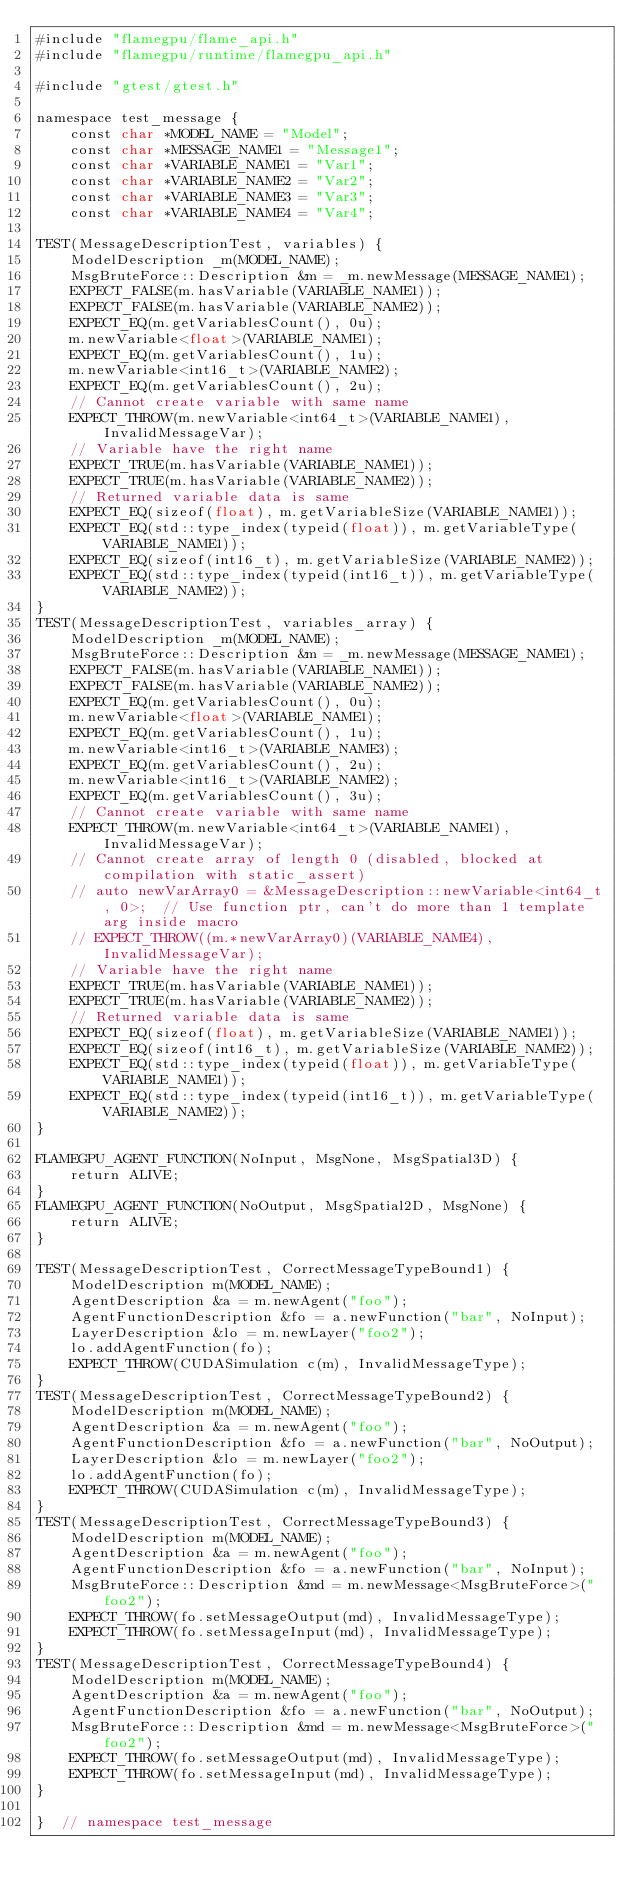<code> <loc_0><loc_0><loc_500><loc_500><_Cuda_>#include "flamegpu/flame_api.h"
#include "flamegpu/runtime/flamegpu_api.h"

#include "gtest/gtest.h"

namespace test_message {
    const char *MODEL_NAME = "Model";
    const char *MESSAGE_NAME1 = "Message1";
    const char *VARIABLE_NAME1 = "Var1";
    const char *VARIABLE_NAME2 = "Var2";
    const char *VARIABLE_NAME3 = "Var3";
    const char *VARIABLE_NAME4 = "Var4";

TEST(MessageDescriptionTest, variables) {
    ModelDescription _m(MODEL_NAME);
    MsgBruteForce::Description &m = _m.newMessage(MESSAGE_NAME1);
    EXPECT_FALSE(m.hasVariable(VARIABLE_NAME1));
    EXPECT_FALSE(m.hasVariable(VARIABLE_NAME2));
    EXPECT_EQ(m.getVariablesCount(), 0u);
    m.newVariable<float>(VARIABLE_NAME1);
    EXPECT_EQ(m.getVariablesCount(), 1u);
    m.newVariable<int16_t>(VARIABLE_NAME2);
    EXPECT_EQ(m.getVariablesCount(), 2u);
    // Cannot create variable with same name
    EXPECT_THROW(m.newVariable<int64_t>(VARIABLE_NAME1), InvalidMessageVar);
    // Variable have the right name
    EXPECT_TRUE(m.hasVariable(VARIABLE_NAME1));
    EXPECT_TRUE(m.hasVariable(VARIABLE_NAME2));
    // Returned variable data is same
    EXPECT_EQ(sizeof(float), m.getVariableSize(VARIABLE_NAME1));
    EXPECT_EQ(std::type_index(typeid(float)), m.getVariableType(VARIABLE_NAME1));
    EXPECT_EQ(sizeof(int16_t), m.getVariableSize(VARIABLE_NAME2));
    EXPECT_EQ(std::type_index(typeid(int16_t)), m.getVariableType(VARIABLE_NAME2));
}
TEST(MessageDescriptionTest, variables_array) {
    ModelDescription _m(MODEL_NAME);
    MsgBruteForce::Description &m = _m.newMessage(MESSAGE_NAME1);
    EXPECT_FALSE(m.hasVariable(VARIABLE_NAME1));
    EXPECT_FALSE(m.hasVariable(VARIABLE_NAME2));
    EXPECT_EQ(m.getVariablesCount(), 0u);
    m.newVariable<float>(VARIABLE_NAME1);
    EXPECT_EQ(m.getVariablesCount(), 1u);
    m.newVariable<int16_t>(VARIABLE_NAME3);
    EXPECT_EQ(m.getVariablesCount(), 2u);
    m.newVariable<int16_t>(VARIABLE_NAME2);
    EXPECT_EQ(m.getVariablesCount(), 3u);
    // Cannot create variable with same name
    EXPECT_THROW(m.newVariable<int64_t>(VARIABLE_NAME1), InvalidMessageVar);
    // Cannot create array of length 0 (disabled, blocked at compilation with static_assert)
    // auto newVarArray0 = &MessageDescription::newVariable<int64_t, 0>;  // Use function ptr, can't do more than 1 template arg inside macro
    // EXPECT_THROW((m.*newVarArray0)(VARIABLE_NAME4), InvalidMessageVar);
    // Variable have the right name
    EXPECT_TRUE(m.hasVariable(VARIABLE_NAME1));
    EXPECT_TRUE(m.hasVariable(VARIABLE_NAME2));
    // Returned variable data is same
    EXPECT_EQ(sizeof(float), m.getVariableSize(VARIABLE_NAME1));
    EXPECT_EQ(sizeof(int16_t), m.getVariableSize(VARIABLE_NAME2));
    EXPECT_EQ(std::type_index(typeid(float)), m.getVariableType(VARIABLE_NAME1));
    EXPECT_EQ(std::type_index(typeid(int16_t)), m.getVariableType(VARIABLE_NAME2));
}

FLAMEGPU_AGENT_FUNCTION(NoInput, MsgNone, MsgSpatial3D) {
    return ALIVE;
}
FLAMEGPU_AGENT_FUNCTION(NoOutput, MsgSpatial2D, MsgNone) {
    return ALIVE;
}

TEST(MessageDescriptionTest, CorrectMessageTypeBound1) {
    ModelDescription m(MODEL_NAME);
    AgentDescription &a = m.newAgent("foo");
    AgentFunctionDescription &fo = a.newFunction("bar", NoInput);
    LayerDescription &lo = m.newLayer("foo2");
    lo.addAgentFunction(fo);
    EXPECT_THROW(CUDASimulation c(m), InvalidMessageType);
}
TEST(MessageDescriptionTest, CorrectMessageTypeBound2) {
    ModelDescription m(MODEL_NAME);
    AgentDescription &a = m.newAgent("foo");
    AgentFunctionDescription &fo = a.newFunction("bar", NoOutput);
    LayerDescription &lo = m.newLayer("foo2");
    lo.addAgentFunction(fo);
    EXPECT_THROW(CUDASimulation c(m), InvalidMessageType);
}
TEST(MessageDescriptionTest, CorrectMessageTypeBound3) {
    ModelDescription m(MODEL_NAME);
    AgentDescription &a = m.newAgent("foo");
    AgentFunctionDescription &fo = a.newFunction("bar", NoInput);
    MsgBruteForce::Description &md = m.newMessage<MsgBruteForce>("foo2");
    EXPECT_THROW(fo.setMessageOutput(md), InvalidMessageType);
    EXPECT_THROW(fo.setMessageInput(md), InvalidMessageType);
}
TEST(MessageDescriptionTest, CorrectMessageTypeBound4) {
    ModelDescription m(MODEL_NAME);
    AgentDescription &a = m.newAgent("foo");
    AgentFunctionDescription &fo = a.newFunction("bar", NoOutput);
    MsgBruteForce::Description &md = m.newMessage<MsgBruteForce>("foo2");
    EXPECT_THROW(fo.setMessageOutput(md), InvalidMessageType);
    EXPECT_THROW(fo.setMessageInput(md), InvalidMessageType);
}

}  // namespace test_message
</code> 